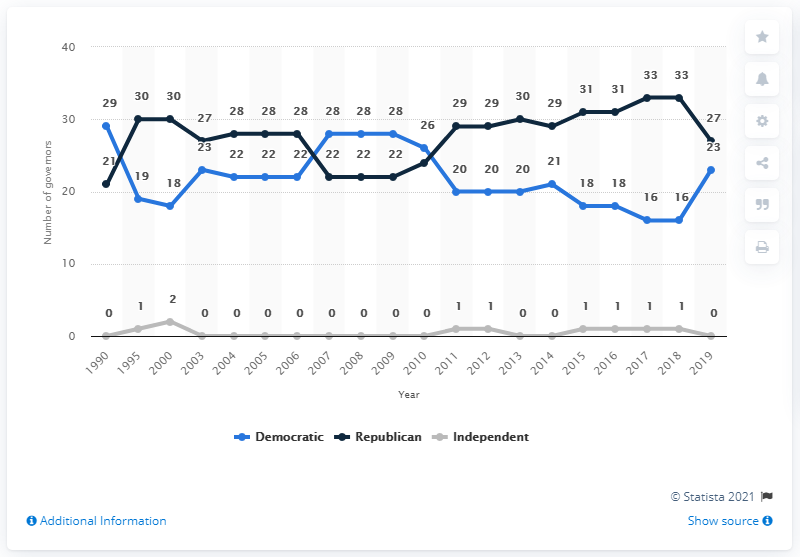Outline some significant characteristics in this image. There were 23 Democratic governors in 2019. Since at least 1990, the number of both Republican and Democratic governors has consistently fluctuated. In 2019, there were 27 Republican governors. 